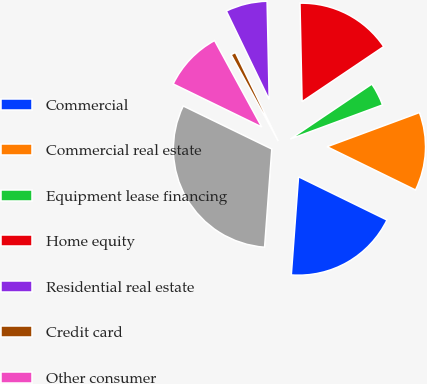Convert chart. <chart><loc_0><loc_0><loc_500><loc_500><pie_chart><fcel>Commercial<fcel>Commercial real estate<fcel>Equipment lease financing<fcel>Home equity<fcel>Residential real estate<fcel>Credit card<fcel>Other consumer<fcel>Total<nl><fcel>18.93%<fcel>12.88%<fcel>3.8%<fcel>15.9%<fcel>6.83%<fcel>0.78%<fcel>9.85%<fcel>31.03%<nl></chart> 